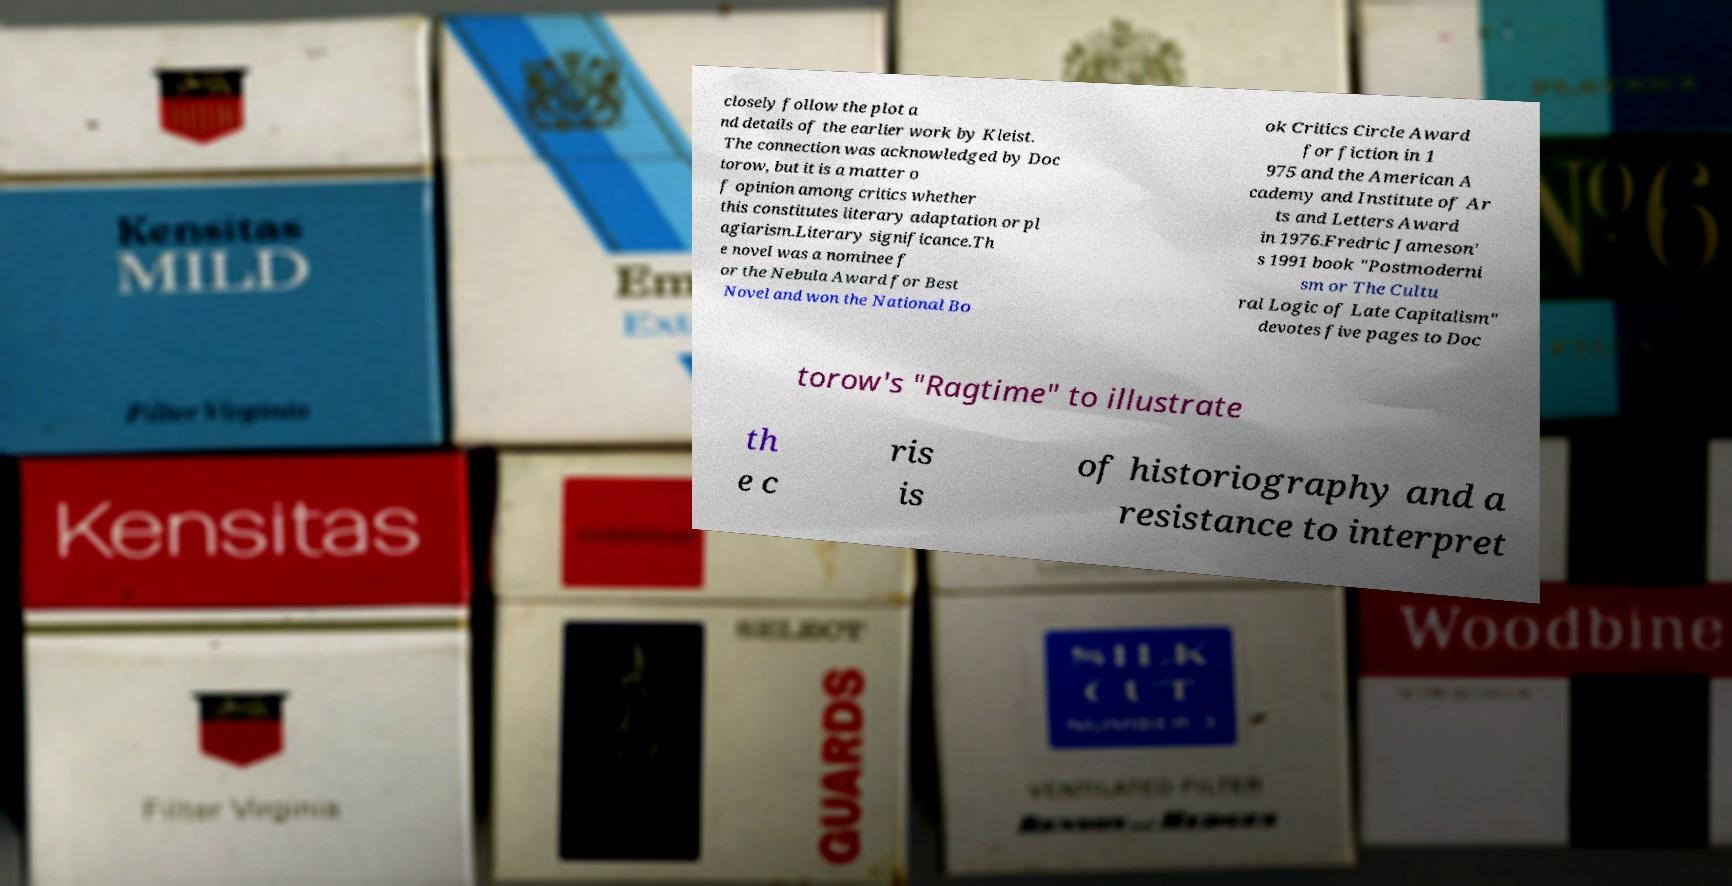I need the written content from this picture converted into text. Can you do that? closely follow the plot a nd details of the earlier work by Kleist. The connection was acknowledged by Doc torow, but it is a matter o f opinion among critics whether this constitutes literary adaptation or pl agiarism.Literary significance.Th e novel was a nominee f or the Nebula Award for Best Novel and won the National Bo ok Critics Circle Award for fiction in 1 975 and the American A cademy and Institute of Ar ts and Letters Award in 1976.Fredric Jameson' s 1991 book "Postmoderni sm or The Cultu ral Logic of Late Capitalism" devotes five pages to Doc torow's "Ragtime" to illustrate th e c ris is of historiography and a resistance to interpret 